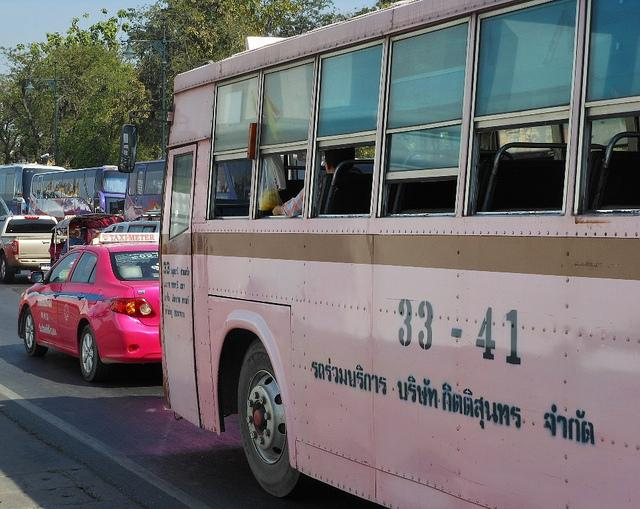What continent is this road located at? Please explain your reasoning. asia. The bus has filipino writing on it. the philippines are in asia. 